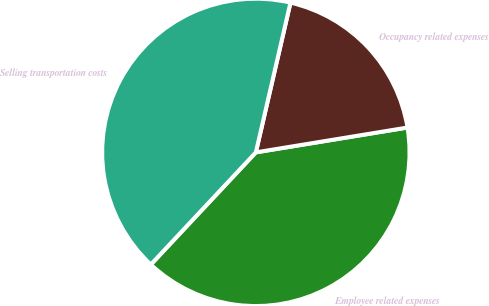<chart> <loc_0><loc_0><loc_500><loc_500><pie_chart><fcel>Employee related expenses<fcel>Occupancy related expenses<fcel>Selling transportation costs<nl><fcel>39.56%<fcel>18.8%<fcel>41.64%<nl></chart> 